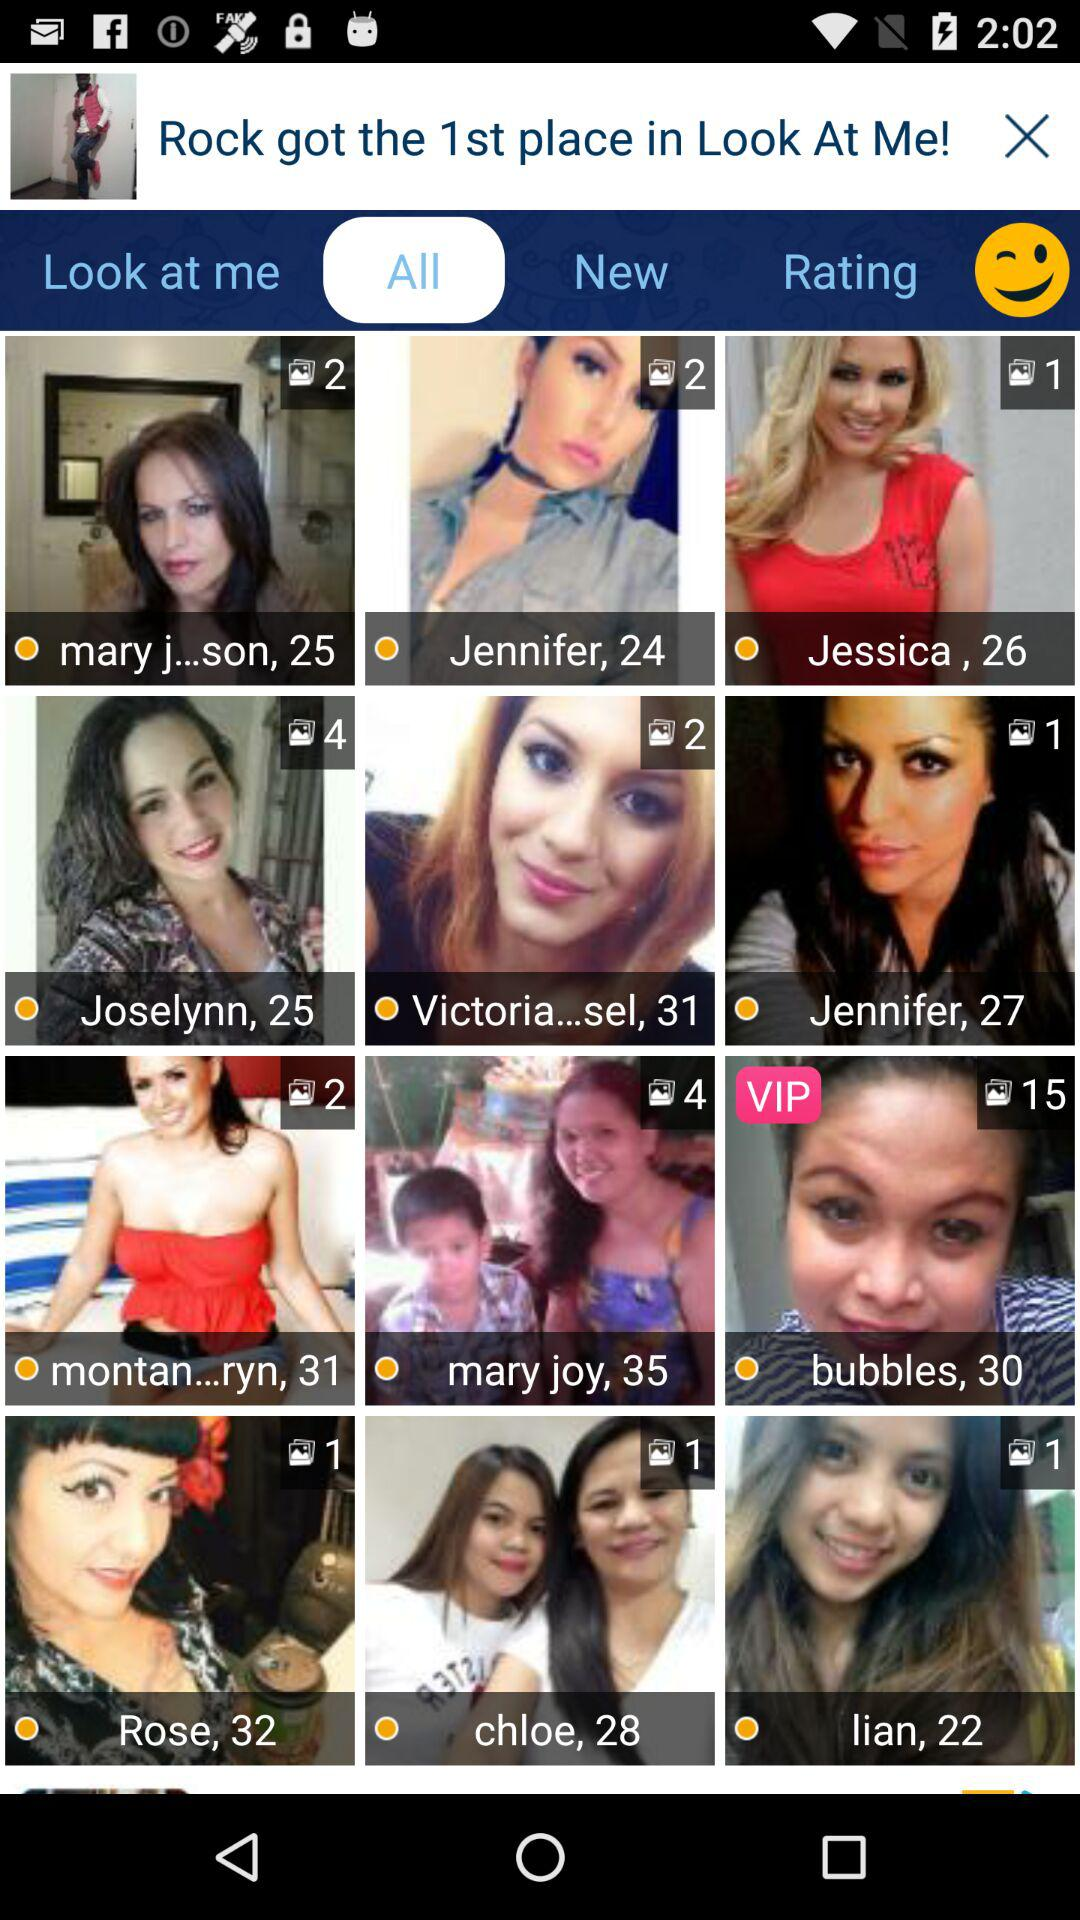How many selfies have a VIP badge?
Answer the question using a single word or phrase. 1 